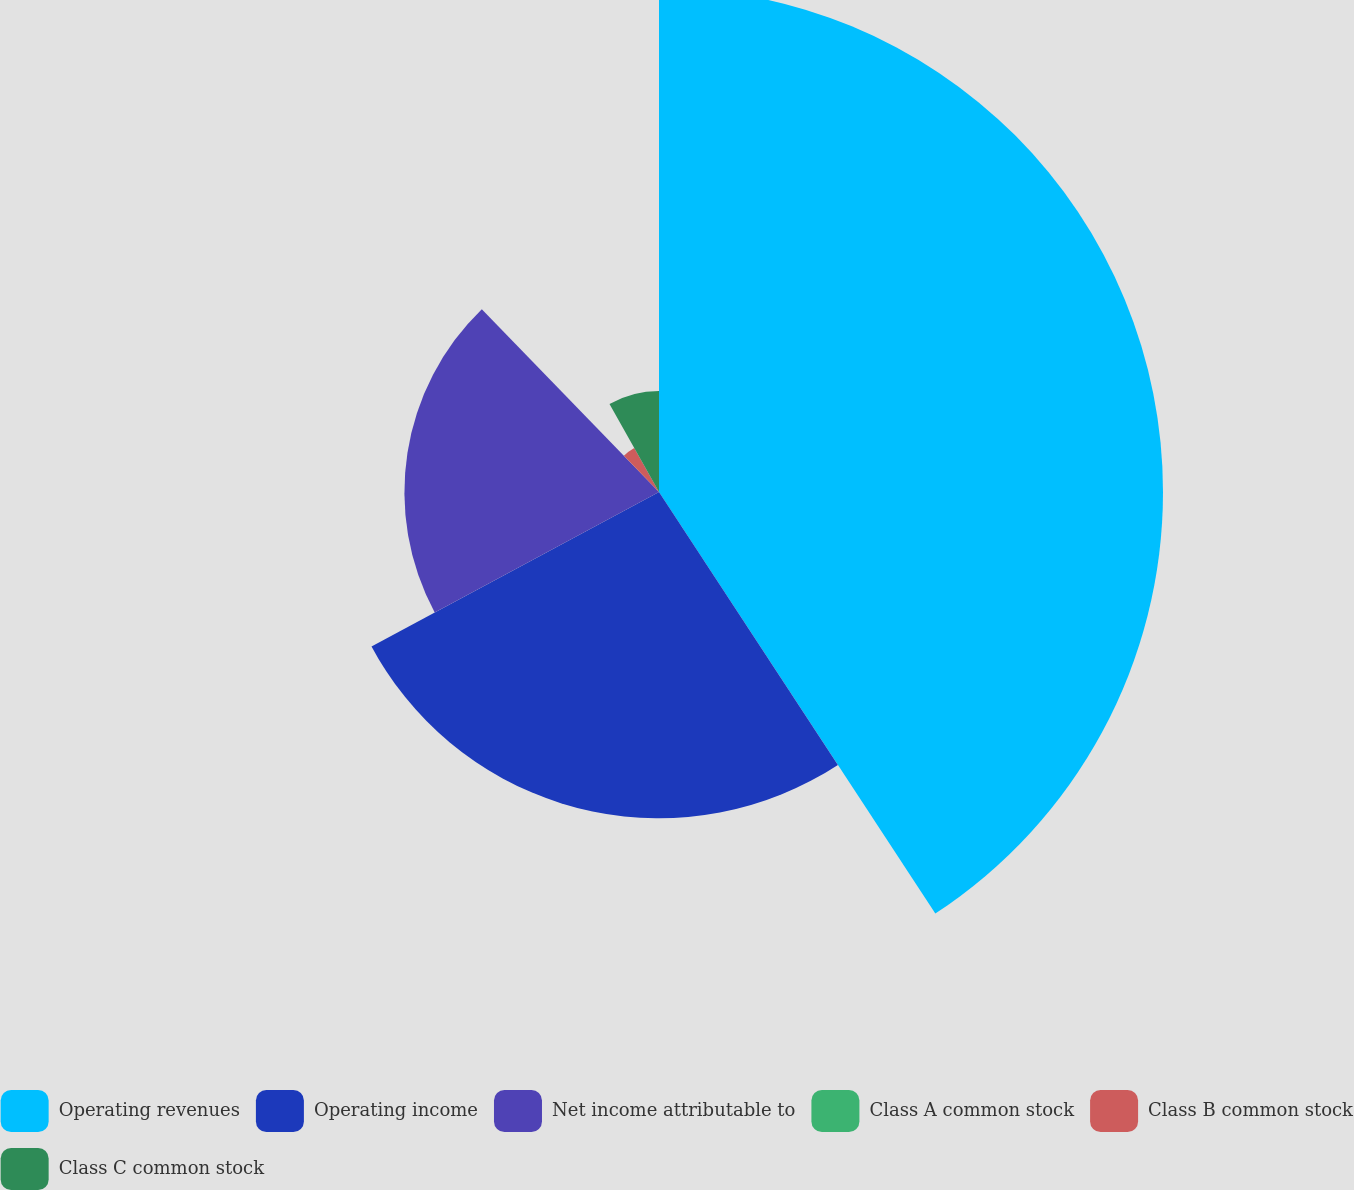Convert chart. <chart><loc_0><loc_0><loc_500><loc_500><pie_chart><fcel>Operating revenues<fcel>Operating income<fcel>Net income attributable to<fcel>Class A common stock<fcel>Class B common stock<fcel>Class C common stock<nl><fcel>40.76%<fcel>26.39%<fcel>20.59%<fcel>0.01%<fcel>4.08%<fcel>8.16%<nl></chart> 